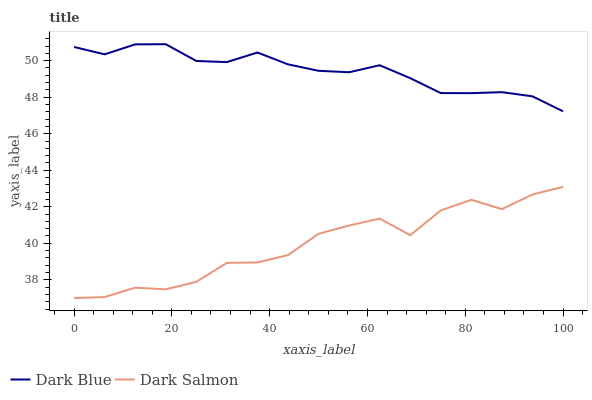Does Dark Salmon have the minimum area under the curve?
Answer yes or no. Yes. Does Dark Blue have the maximum area under the curve?
Answer yes or no. Yes. Does Dark Salmon have the maximum area under the curve?
Answer yes or no. No. Is Dark Blue the smoothest?
Answer yes or no. Yes. Is Dark Salmon the roughest?
Answer yes or no. Yes. Is Dark Salmon the smoothest?
Answer yes or no. No. Does Dark Salmon have the highest value?
Answer yes or no. No. Is Dark Salmon less than Dark Blue?
Answer yes or no. Yes. Is Dark Blue greater than Dark Salmon?
Answer yes or no. Yes. Does Dark Salmon intersect Dark Blue?
Answer yes or no. No. 